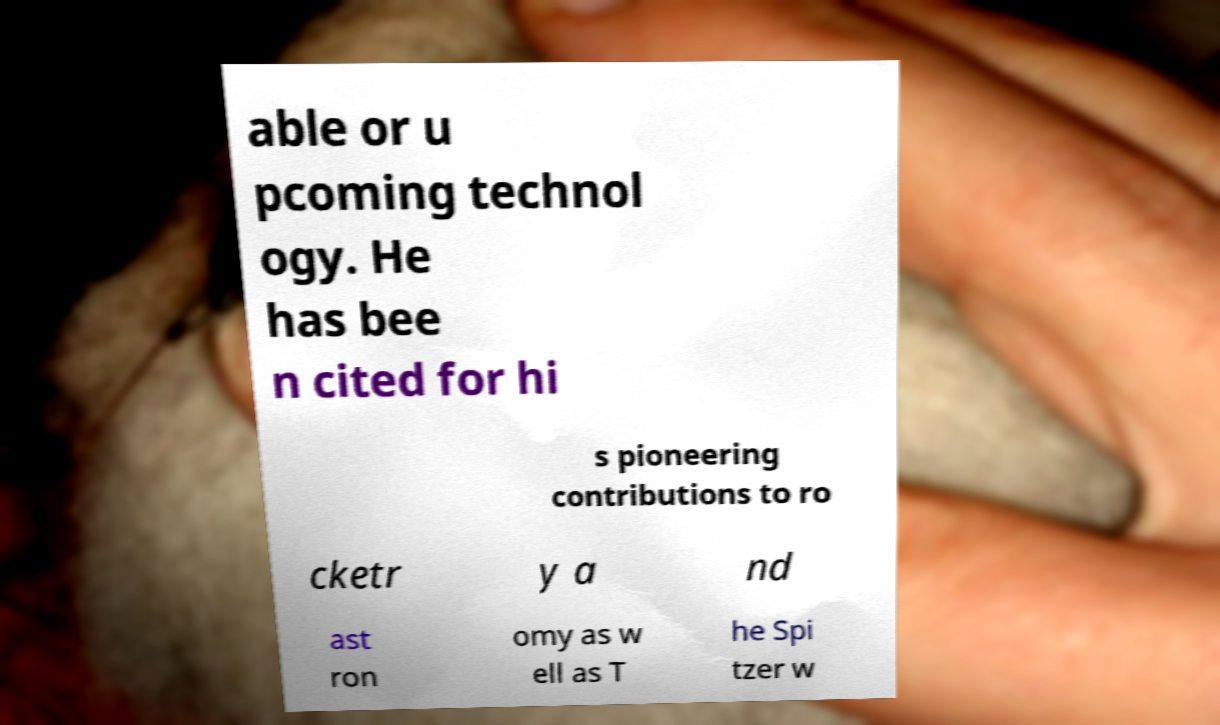What messages or text are displayed in this image? I need them in a readable, typed format. able or u pcoming technol ogy. He has bee n cited for hi s pioneering contributions to ro cketr y a nd ast ron omy as w ell as T he Spi tzer w 